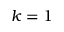Convert formula to latex. <formula><loc_0><loc_0><loc_500><loc_500>k = 1</formula> 